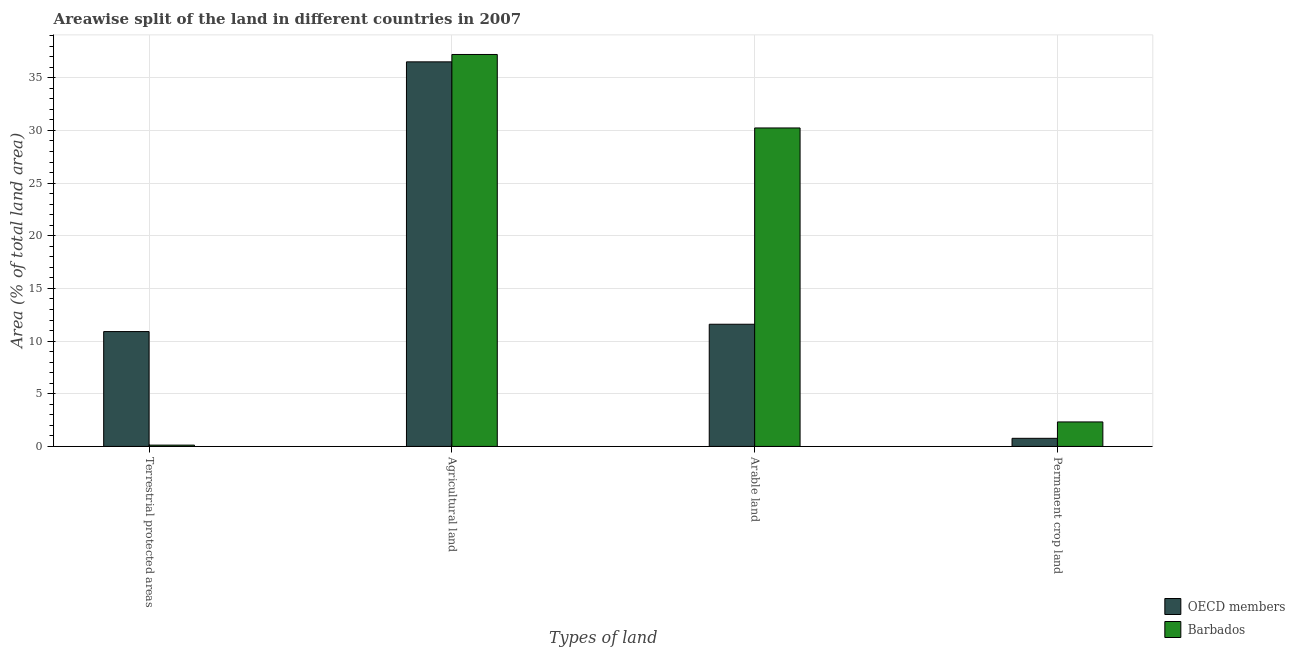How many different coloured bars are there?
Offer a terse response. 2. How many bars are there on the 1st tick from the right?
Keep it short and to the point. 2. What is the label of the 2nd group of bars from the left?
Your response must be concise. Agricultural land. What is the percentage of area under agricultural land in OECD members?
Your answer should be compact. 36.51. Across all countries, what is the maximum percentage of area under permanent crop land?
Your answer should be compact. 2.33. Across all countries, what is the minimum percentage of land under terrestrial protection?
Give a very brief answer. 0.12. What is the total percentage of area under permanent crop land in the graph?
Your response must be concise. 3.1. What is the difference between the percentage of area under agricultural land in OECD members and that in Barbados?
Ensure brevity in your answer.  -0.7. What is the difference between the percentage of land under terrestrial protection in OECD members and the percentage of area under permanent crop land in Barbados?
Ensure brevity in your answer.  8.58. What is the average percentage of area under agricultural land per country?
Ensure brevity in your answer.  36.86. What is the difference between the percentage of area under agricultural land and percentage of area under arable land in OECD members?
Your answer should be very brief. 24.91. What is the ratio of the percentage of area under permanent crop land in OECD members to that in Barbados?
Provide a short and direct response. 0.33. Is the percentage of area under permanent crop land in Barbados less than that in OECD members?
Offer a very short reply. No. What is the difference between the highest and the second highest percentage of area under agricultural land?
Give a very brief answer. 0.7. What is the difference between the highest and the lowest percentage of area under arable land?
Ensure brevity in your answer.  18.63. Is the sum of the percentage of land under terrestrial protection in OECD members and Barbados greater than the maximum percentage of area under arable land across all countries?
Offer a terse response. No. Is it the case that in every country, the sum of the percentage of area under arable land and percentage of area under agricultural land is greater than the sum of percentage of area under permanent crop land and percentage of land under terrestrial protection?
Give a very brief answer. No. What does the 2nd bar from the left in Permanent crop land represents?
Ensure brevity in your answer.  Barbados. Is it the case that in every country, the sum of the percentage of land under terrestrial protection and percentage of area under agricultural land is greater than the percentage of area under arable land?
Your response must be concise. Yes. How many bars are there?
Your answer should be very brief. 8. Are all the bars in the graph horizontal?
Provide a succinct answer. No. What is the difference between two consecutive major ticks on the Y-axis?
Your response must be concise. 5. Are the values on the major ticks of Y-axis written in scientific E-notation?
Provide a short and direct response. No. Does the graph contain grids?
Provide a short and direct response. Yes. How many legend labels are there?
Provide a succinct answer. 2. How are the legend labels stacked?
Give a very brief answer. Vertical. What is the title of the graph?
Make the answer very short. Areawise split of the land in different countries in 2007. What is the label or title of the X-axis?
Keep it short and to the point. Types of land. What is the label or title of the Y-axis?
Your answer should be compact. Area (% of total land area). What is the Area (% of total land area) of OECD members in Terrestrial protected areas?
Provide a short and direct response. 10.9. What is the Area (% of total land area) of Barbados in Terrestrial protected areas?
Provide a succinct answer. 0.12. What is the Area (% of total land area) in OECD members in Agricultural land?
Your response must be concise. 36.51. What is the Area (% of total land area) in Barbados in Agricultural land?
Your answer should be very brief. 37.21. What is the Area (% of total land area) of OECD members in Arable land?
Ensure brevity in your answer.  11.6. What is the Area (% of total land area) in Barbados in Arable land?
Your answer should be very brief. 30.23. What is the Area (% of total land area) of OECD members in Permanent crop land?
Give a very brief answer. 0.77. What is the Area (% of total land area) in Barbados in Permanent crop land?
Provide a short and direct response. 2.33. Across all Types of land, what is the maximum Area (% of total land area) of OECD members?
Offer a terse response. 36.51. Across all Types of land, what is the maximum Area (% of total land area) of Barbados?
Offer a terse response. 37.21. Across all Types of land, what is the minimum Area (% of total land area) in OECD members?
Your response must be concise. 0.77. Across all Types of land, what is the minimum Area (% of total land area) in Barbados?
Give a very brief answer. 0.12. What is the total Area (% of total land area) in OECD members in the graph?
Ensure brevity in your answer.  59.78. What is the total Area (% of total land area) of Barbados in the graph?
Ensure brevity in your answer.  69.89. What is the difference between the Area (% of total land area) of OECD members in Terrestrial protected areas and that in Agricultural land?
Give a very brief answer. -25.6. What is the difference between the Area (% of total land area) of Barbados in Terrestrial protected areas and that in Agricultural land?
Offer a terse response. -37.09. What is the difference between the Area (% of total land area) of OECD members in Terrestrial protected areas and that in Arable land?
Make the answer very short. -0.7. What is the difference between the Area (% of total land area) in Barbados in Terrestrial protected areas and that in Arable land?
Your response must be concise. -30.11. What is the difference between the Area (% of total land area) in OECD members in Terrestrial protected areas and that in Permanent crop land?
Give a very brief answer. 10.13. What is the difference between the Area (% of total land area) of Barbados in Terrestrial protected areas and that in Permanent crop land?
Provide a succinct answer. -2.2. What is the difference between the Area (% of total land area) of OECD members in Agricultural land and that in Arable land?
Your answer should be compact. 24.91. What is the difference between the Area (% of total land area) in Barbados in Agricultural land and that in Arable land?
Provide a succinct answer. 6.98. What is the difference between the Area (% of total land area) in OECD members in Agricultural land and that in Permanent crop land?
Your answer should be compact. 35.74. What is the difference between the Area (% of total land area) of Barbados in Agricultural land and that in Permanent crop land?
Offer a terse response. 34.88. What is the difference between the Area (% of total land area) of OECD members in Arable land and that in Permanent crop land?
Ensure brevity in your answer.  10.83. What is the difference between the Area (% of total land area) in Barbados in Arable land and that in Permanent crop land?
Offer a terse response. 27.91. What is the difference between the Area (% of total land area) of OECD members in Terrestrial protected areas and the Area (% of total land area) of Barbados in Agricultural land?
Keep it short and to the point. -26.31. What is the difference between the Area (% of total land area) in OECD members in Terrestrial protected areas and the Area (% of total land area) in Barbados in Arable land?
Your answer should be compact. -19.33. What is the difference between the Area (% of total land area) in OECD members in Terrestrial protected areas and the Area (% of total land area) in Barbados in Permanent crop land?
Your response must be concise. 8.58. What is the difference between the Area (% of total land area) of OECD members in Agricultural land and the Area (% of total land area) of Barbados in Arable land?
Give a very brief answer. 6.28. What is the difference between the Area (% of total land area) of OECD members in Agricultural land and the Area (% of total land area) of Barbados in Permanent crop land?
Ensure brevity in your answer.  34.18. What is the difference between the Area (% of total land area) in OECD members in Arable land and the Area (% of total land area) in Barbados in Permanent crop land?
Your answer should be very brief. 9.27. What is the average Area (% of total land area) in OECD members per Types of land?
Ensure brevity in your answer.  14.95. What is the average Area (% of total land area) of Barbados per Types of land?
Provide a succinct answer. 17.47. What is the difference between the Area (% of total land area) in OECD members and Area (% of total land area) in Barbados in Terrestrial protected areas?
Your answer should be compact. 10.78. What is the difference between the Area (% of total land area) of OECD members and Area (% of total land area) of Barbados in Agricultural land?
Offer a very short reply. -0.7. What is the difference between the Area (% of total land area) of OECD members and Area (% of total land area) of Barbados in Arable land?
Make the answer very short. -18.63. What is the difference between the Area (% of total land area) in OECD members and Area (% of total land area) in Barbados in Permanent crop land?
Your answer should be very brief. -1.56. What is the ratio of the Area (% of total land area) of OECD members in Terrestrial protected areas to that in Agricultural land?
Make the answer very short. 0.3. What is the ratio of the Area (% of total land area) of Barbados in Terrestrial protected areas to that in Agricultural land?
Your response must be concise. 0. What is the ratio of the Area (% of total land area) of OECD members in Terrestrial protected areas to that in Arable land?
Your answer should be compact. 0.94. What is the ratio of the Area (% of total land area) in Barbados in Terrestrial protected areas to that in Arable land?
Make the answer very short. 0. What is the ratio of the Area (% of total land area) of OECD members in Terrestrial protected areas to that in Permanent crop land?
Provide a succinct answer. 14.15. What is the ratio of the Area (% of total land area) in Barbados in Terrestrial protected areas to that in Permanent crop land?
Your answer should be very brief. 0.05. What is the ratio of the Area (% of total land area) in OECD members in Agricultural land to that in Arable land?
Offer a terse response. 3.15. What is the ratio of the Area (% of total land area) of Barbados in Agricultural land to that in Arable land?
Your answer should be compact. 1.23. What is the ratio of the Area (% of total land area) in OECD members in Agricultural land to that in Permanent crop land?
Offer a very short reply. 47.38. What is the ratio of the Area (% of total land area) in OECD members in Arable land to that in Permanent crop land?
Your answer should be compact. 15.06. What is the difference between the highest and the second highest Area (% of total land area) in OECD members?
Ensure brevity in your answer.  24.91. What is the difference between the highest and the second highest Area (% of total land area) of Barbados?
Ensure brevity in your answer.  6.98. What is the difference between the highest and the lowest Area (% of total land area) in OECD members?
Your response must be concise. 35.74. What is the difference between the highest and the lowest Area (% of total land area) of Barbados?
Ensure brevity in your answer.  37.09. 